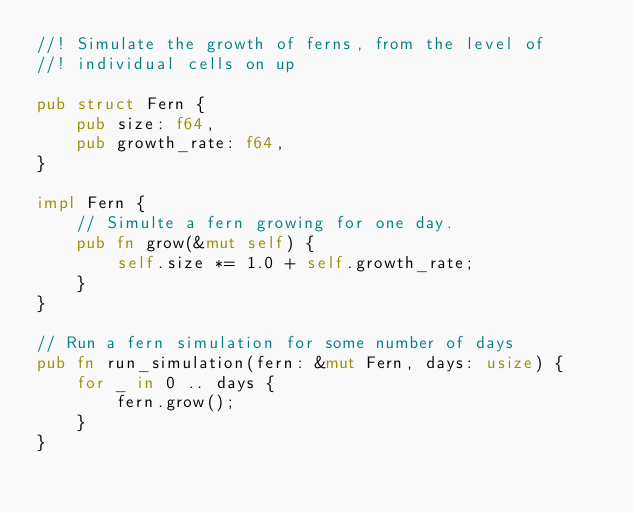Convert code to text. <code><loc_0><loc_0><loc_500><loc_500><_Rust_>//! Simulate the growth of ferns, from the level of
//! individual cells on up

pub struct Fern {
    pub size: f64,
    pub growth_rate: f64,
}

impl Fern {
    // Simulte a fern growing for one day.
    pub fn grow(&mut self) {
        self.size *= 1.0 + self.growth_rate;
    }
}

// Run a fern simulation for some number of days
pub fn run_simulation(fern: &mut Fern, days: usize) {
    for _ in 0 .. days {
        fern.grow();
    }
}
</code> 